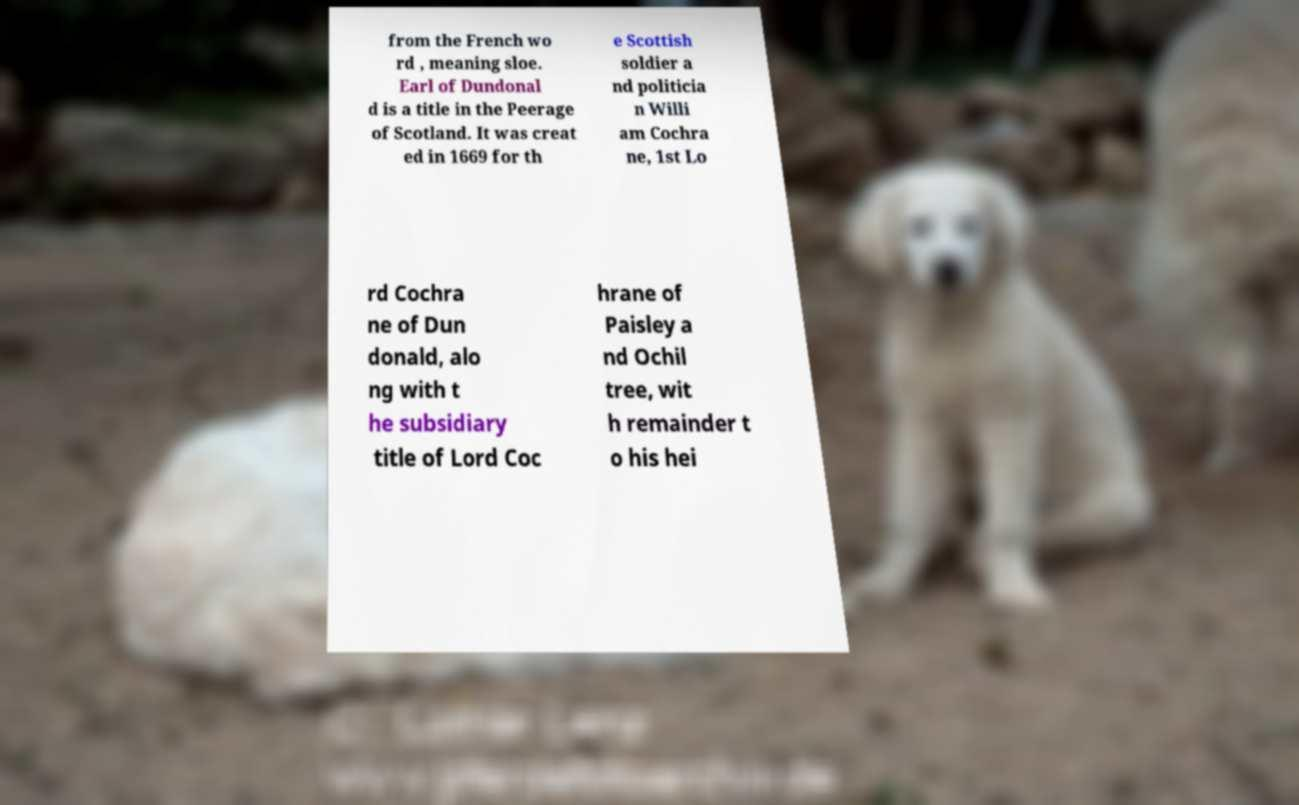Please identify and transcribe the text found in this image. from the French wo rd , meaning sloe. Earl of Dundonal d is a title in the Peerage of Scotland. It was creat ed in 1669 for th e Scottish soldier a nd politicia n Willi am Cochra ne, 1st Lo rd Cochra ne of Dun donald, alo ng with t he subsidiary title of Lord Coc hrane of Paisley a nd Ochil tree, wit h remainder t o his hei 